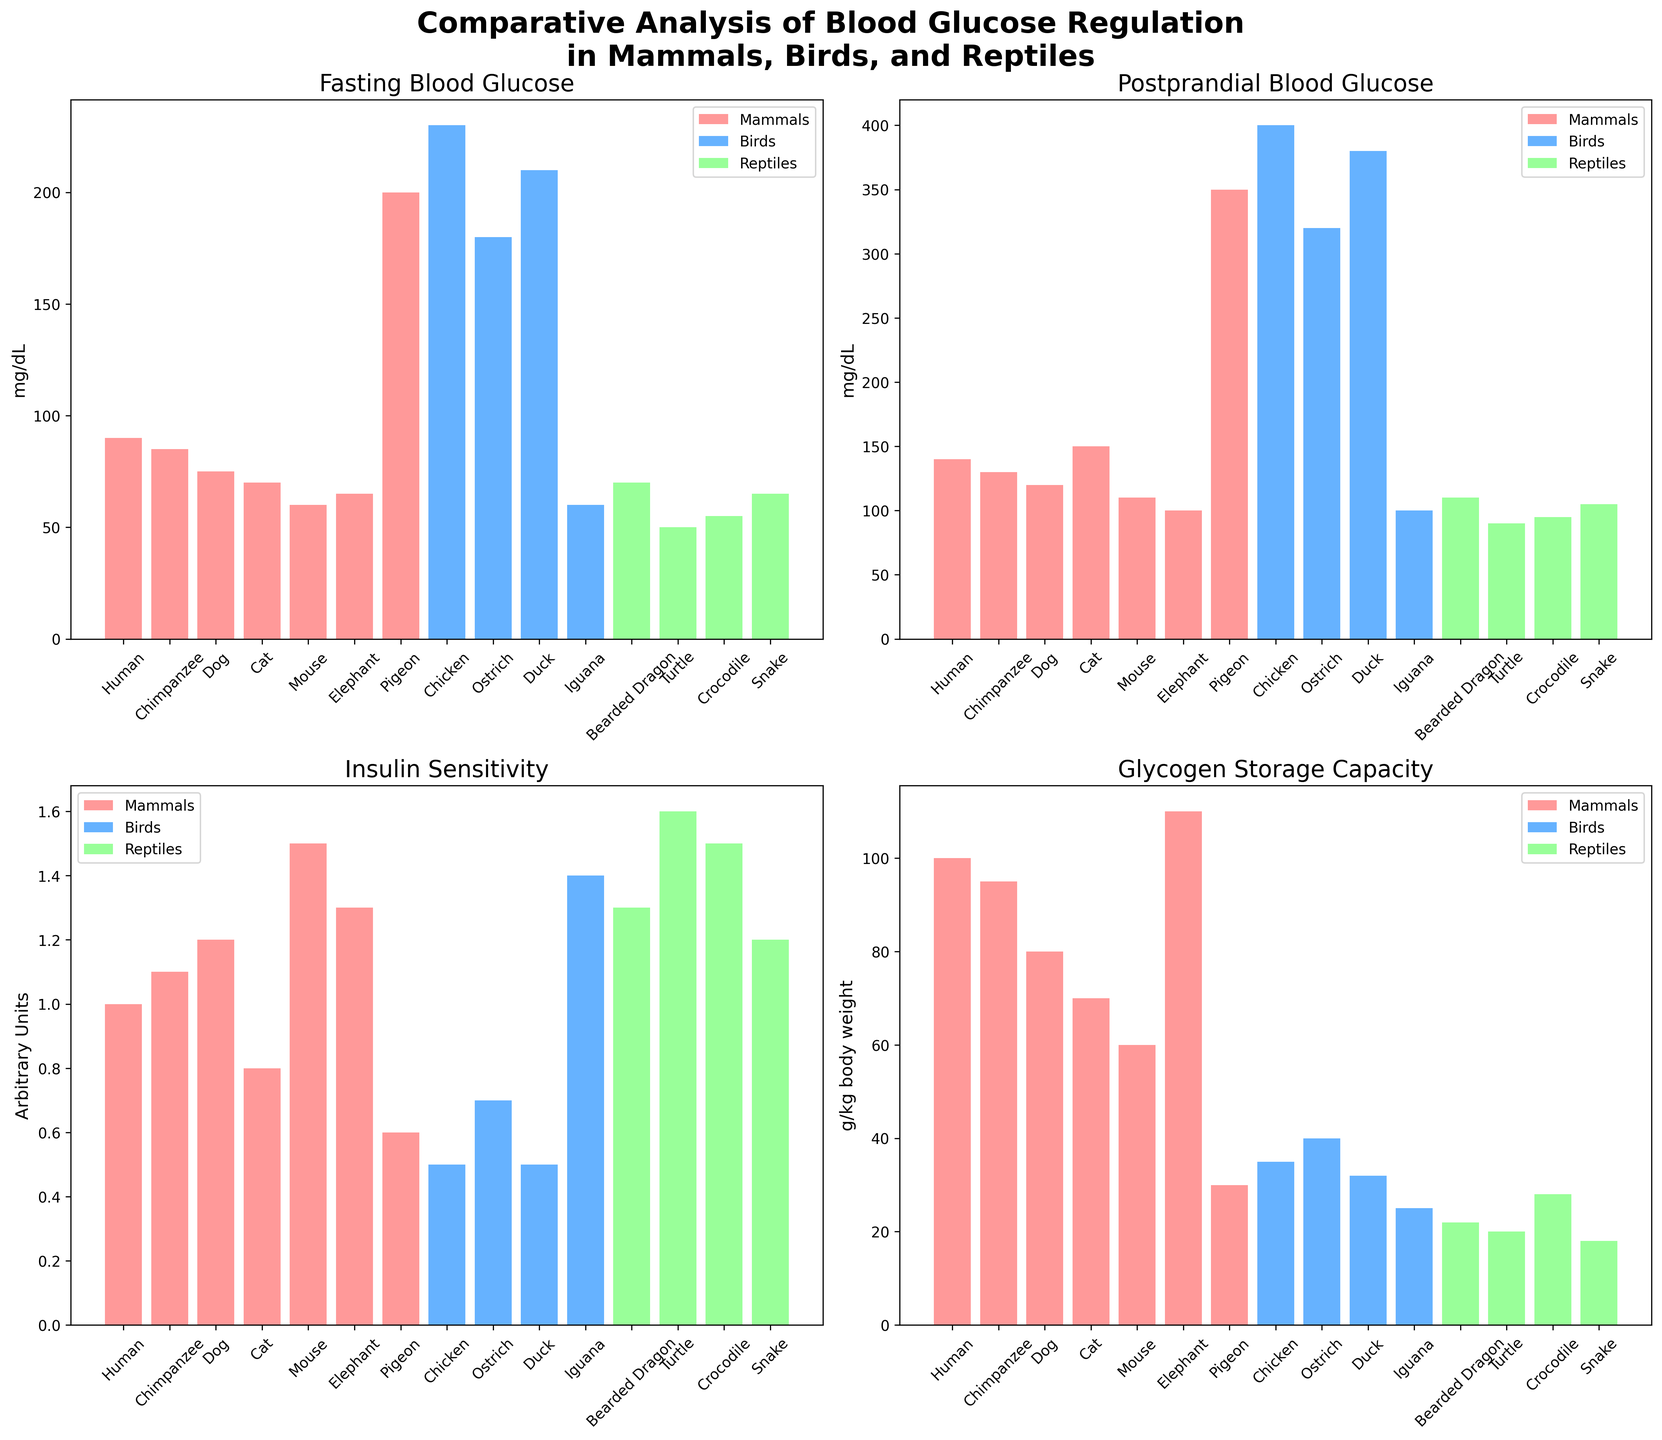Which species among mammals has the highest fasting blood glucose level? According to the bar chart for fasting blood glucose levels, humans have the highest fasting blood glucose level among mammals.
Answer: Human Compare the insulin sensitivity between birds and the reptiles. Which group generally has higher insulin sensitivity? In the insulin sensitivity bar chart, the reptile species have bars that are generally higher than bird species, indicating higher insulin sensitivity in reptiles.
Answer: Reptiles What is the difference between the fasting blood glucose level of a pigeon and a crocodile? The fasting blood glucose level for a pigeon is 200 mg/dL, and for a crocodile, it is 55 mg/dL. The difference is 200 - 55 = 145 mg/dL.
Answer: 145 mg/dL Which species has the lowest postprandial blood glucose level, and what is its value? Observing the postprandial blood glucose levels, the species with the lowest value is the Turtle with 90 mg/dL.
Answer: Turtle - 90 mg/dL Which group has the most variance in glycogen storage capacity? From the bar chart, birds exhibit the most variance in glycogen storage capacity, ranging from about 30 to 40 g/kg body weight compared to the other groups.
Answer: Birds Among mammals, which species has the smallest difference between fasting and postprandial blood glucose levels? For mammals, the difference between fasting and postprandial blood glucose levels can be calculated as follows: Human: 140 - 90 = 50, Chimpanzee: 130 - 85 = 45, Dog: 120 - 75 = 45, Cat: 150 - 70 = 80, Mouse: 110 - 60 = 50, Elephant: 100 - 65 = 35. The elephant has the smallest difference with 35 mg/dL.
Answer: Elephant Considering all species, which group shows the highest average insulin sensitivity? Calculate the average insulin sensitivity for each group: Mammals: (1.0 + 1.1 + 1.2 + 0.8 + 1.5 + 1.3) / 6 = 1.15, Birds: (0.6 + 0.5 + 0.7 + 0.5) / 4 = 0.575, Reptiles: (1.4 + 1.3 + 1.6 + 1.5 + 1.2) / 5 = 1.4. Reptiles have the highest average insulin sensitivity.
Answer: Reptiles 